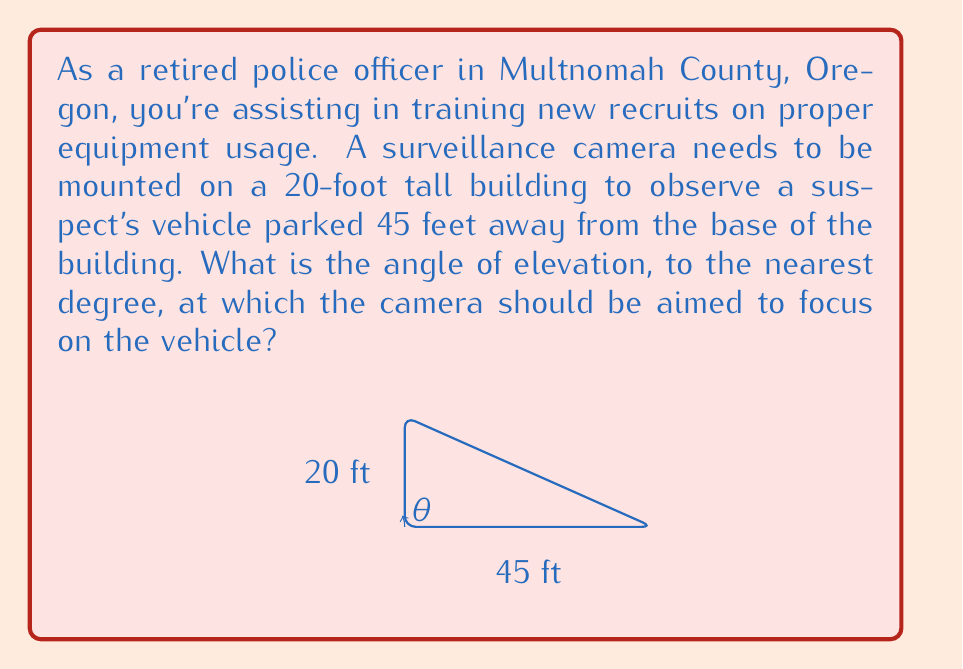Could you help me with this problem? To solve this problem, we need to use trigonometry, specifically the tangent function. Let's break it down step-by-step:

1) In this scenario, we have a right triangle where:
   - The adjacent side (ground distance) is 45 feet
   - The opposite side (height of the building) is 20 feet
   - We need to find the angle $\theta$ at the base of the triangle

2) The tangent of an angle in a right triangle is defined as the ratio of the opposite side to the adjacent side:

   $$\tan(\theta) = \frac{\text{opposite}}{\text{adjacent}} = \frac{\text{height}}{\text{ground distance}}$$

3) Substituting our known values:

   $$\tan(\theta) = \frac{20}{45}$$

4) To find $\theta$, we need to use the inverse tangent (arctan or $\tan^{-1}$) function:

   $$\theta = \tan^{-1}\left(\frac{20}{45}\right)$$

5) Using a calculator or computer:

   $$\theta \approx 23.96^\circ$$

6) Rounding to the nearest degree:

   $$\theta \approx 24^\circ$$

Therefore, the camera should be aimed at an angle of elevation of approximately 24 degrees.
Answer: 24° 